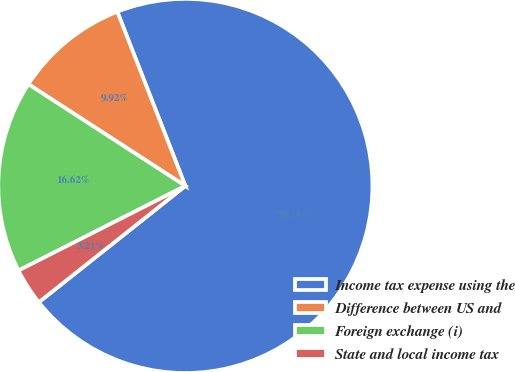<chart> <loc_0><loc_0><loc_500><loc_500><pie_chart><fcel>Income tax expense using the<fcel>Difference between US and<fcel>Foreign exchange (i)<fcel>State and local income tax<nl><fcel>70.25%<fcel>9.92%<fcel>16.62%<fcel>3.21%<nl></chart> 